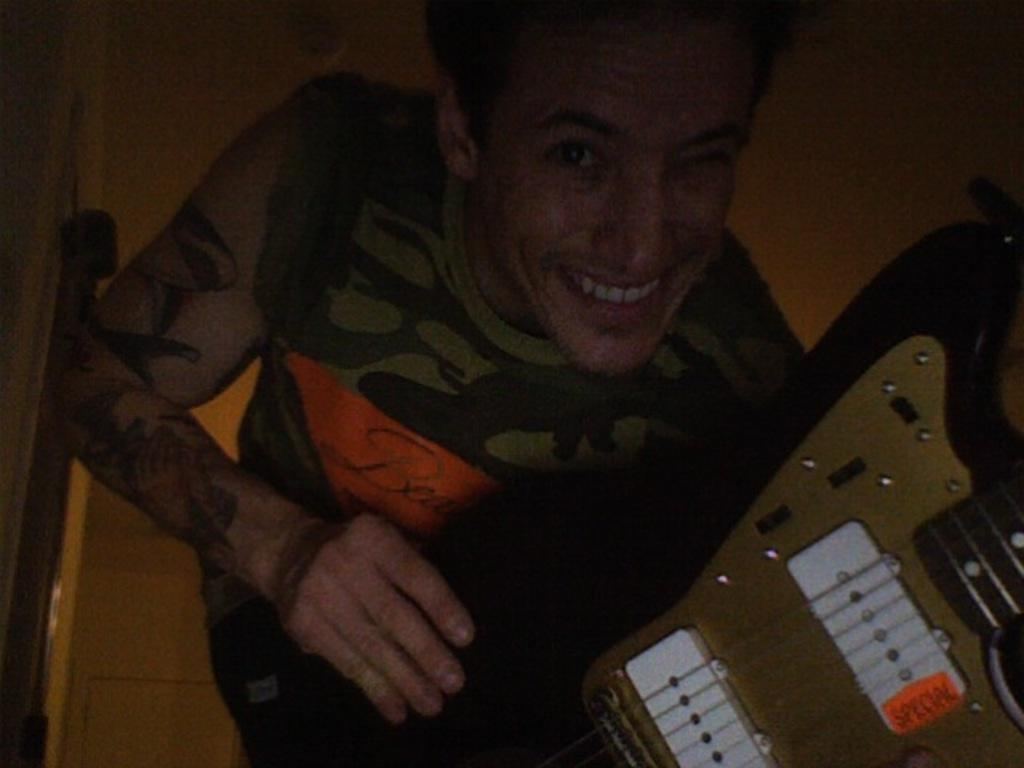Who is present in the image? There is a man in the picture. What is the man holding in the image? The man is holding a guitar. What expression does the man have in the image? The man is smiling. What type of trees can be seen in the background of the image? There are no trees visible in the background of the image; it only features the man holding a guitar and smiling. 